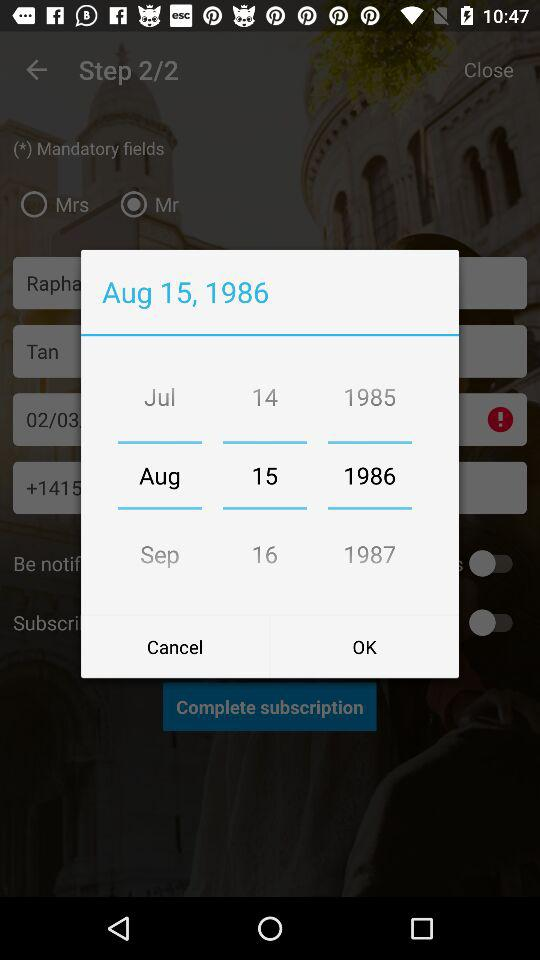What is the selected date? The selected date is August 15, 1986. 